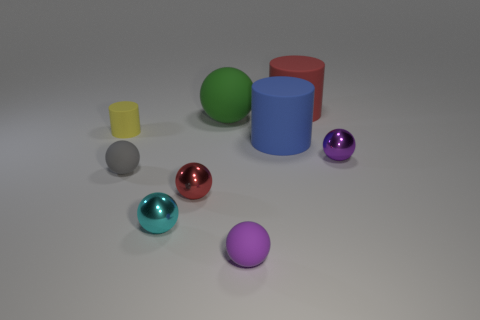How big is the red rubber thing behind the small metal ball that is to the left of the red object in front of the yellow cylinder?
Provide a short and direct response. Large. Is there a red thing made of the same material as the cyan object?
Your response must be concise. Yes. There is a tiny purple matte thing; what shape is it?
Ensure brevity in your answer.  Sphere. There is a tiny cylinder that is the same material as the big green thing; what is its color?
Your response must be concise. Yellow. How many blue objects are big rubber things or cylinders?
Your response must be concise. 1. Are there more green balls than tiny shiny things?
Your answer should be compact. No. What number of things are metal things to the right of the small red sphere or small spheres that are in front of the tiny red shiny thing?
Ensure brevity in your answer.  3. There is a matte cylinder that is the same size as the purple metal object; what is its color?
Keep it short and to the point. Yellow. Do the tiny yellow cylinder and the large ball have the same material?
Keep it short and to the point. Yes. What is the small sphere right of the matte object behind the green matte thing made of?
Give a very brief answer. Metal. 